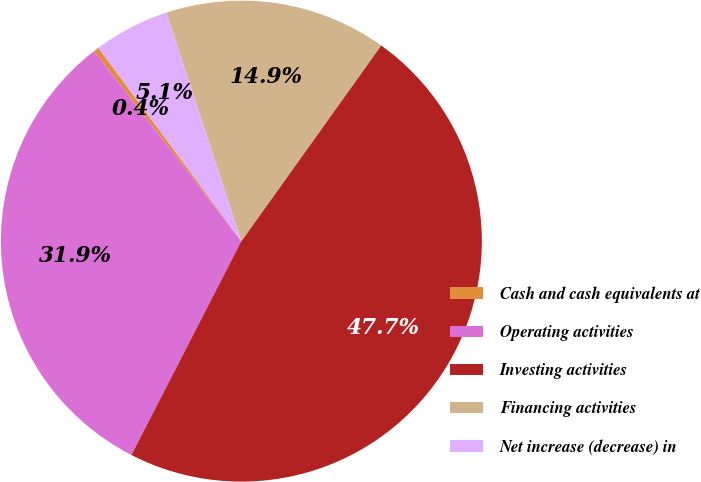Convert chart to OTSL. <chart><loc_0><loc_0><loc_500><loc_500><pie_chart><fcel>Cash and cash equivalents at<fcel>Operating activities<fcel>Investing activities<fcel>Financing activities<fcel>Net increase (decrease) in<nl><fcel>0.36%<fcel>31.95%<fcel>47.69%<fcel>14.92%<fcel>5.09%<nl></chart> 